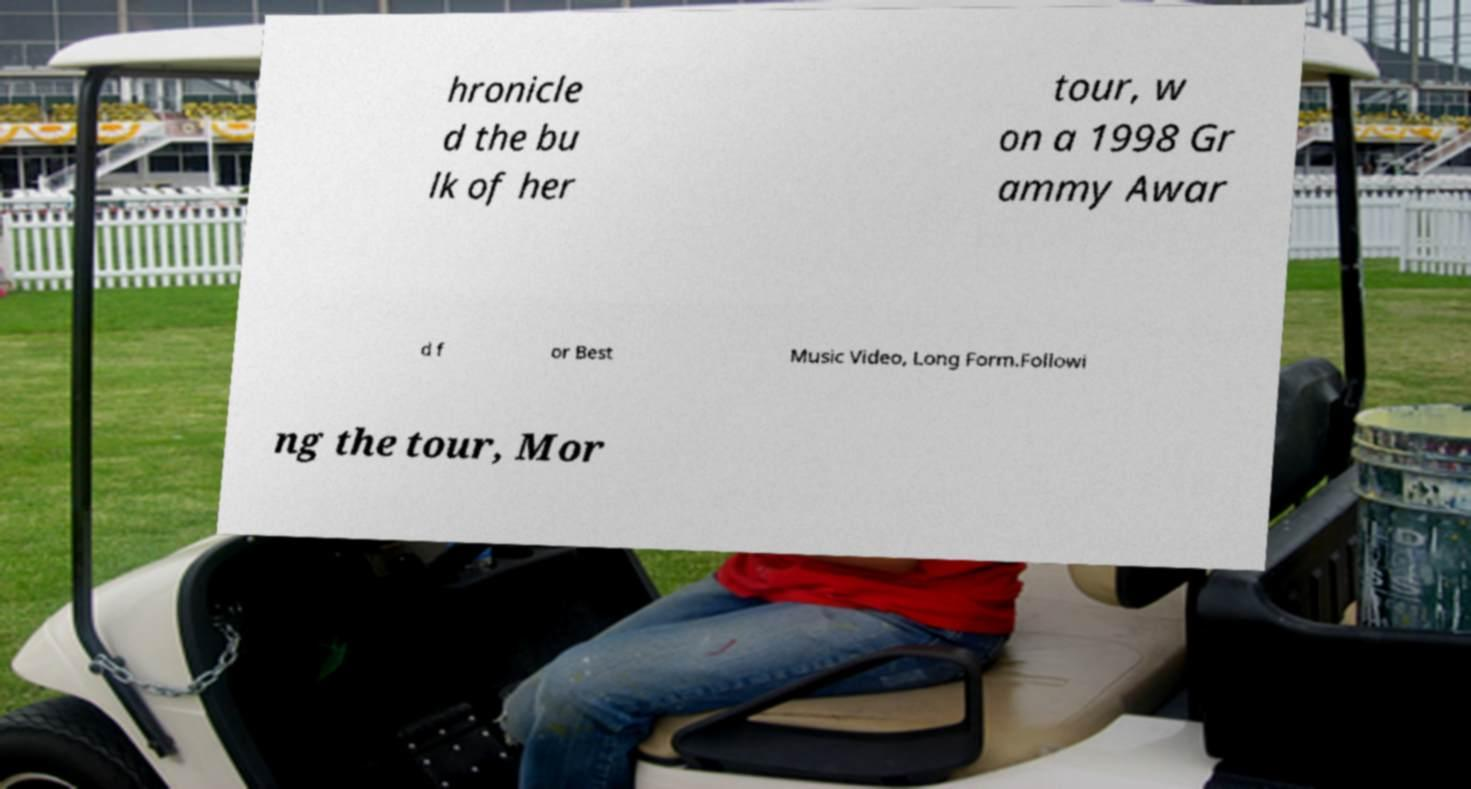Could you assist in decoding the text presented in this image and type it out clearly? hronicle d the bu lk of her tour, w on a 1998 Gr ammy Awar d f or Best Music Video, Long Form.Followi ng the tour, Mor 